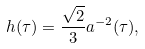<formula> <loc_0><loc_0><loc_500><loc_500>h ( \tau ) = \frac { \sqrt { 2 } } { 3 } a ^ { - 2 } ( \tau ) ,</formula> 